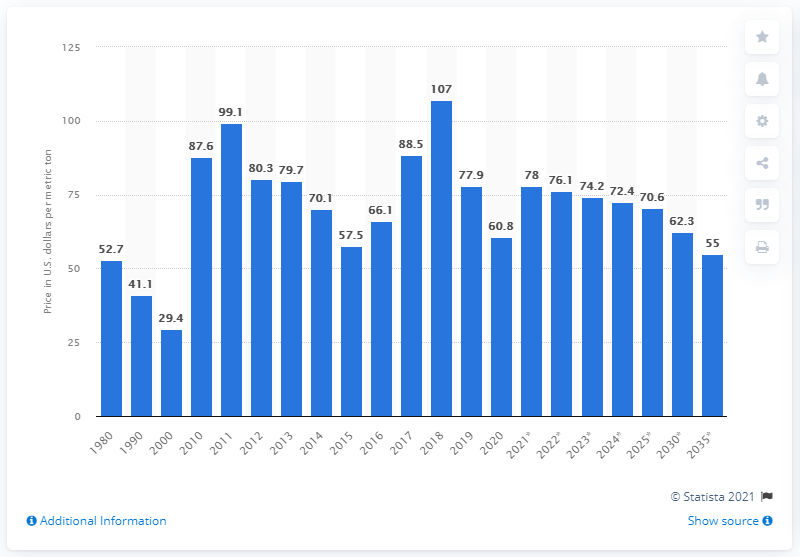Point out several critical features in this image. In 2020, the price of Australian coal was $60.80 per metric ton in dollars. 